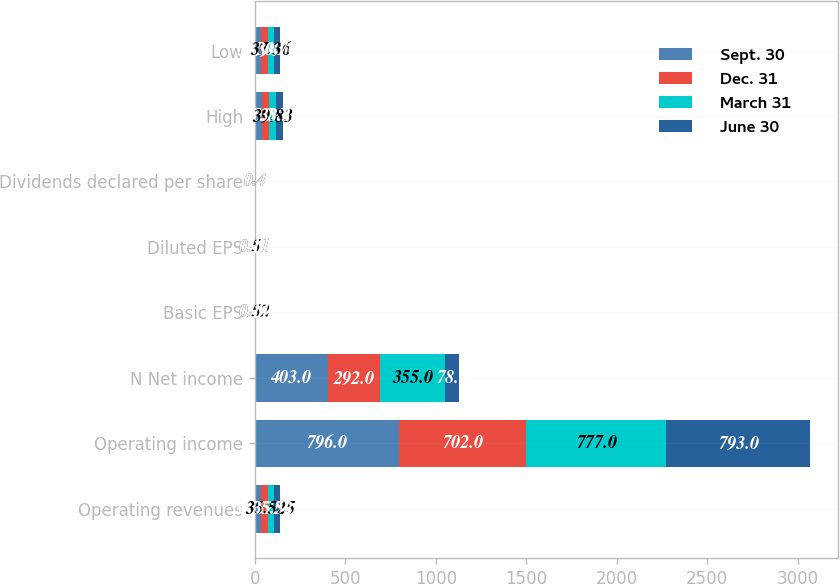<chart> <loc_0><loc_0><loc_500><loc_500><stacked_bar_chart><ecel><fcel>Operating revenues<fcel>Operating income<fcel>N Net income<fcel>Basic EPS<fcel>Diluted EPS<fcel>Dividends declared per share<fcel>High<fcel>Low<nl><fcel>Sept. 30<fcel>35.525<fcel>796<fcel>403<fcel>0.59<fcel>0.59<fcel>0.4<fcel>37.7<fcel>33.94<nl><fcel>Dec. 31<fcel>35.525<fcel>702<fcel>292<fcel>0.43<fcel>0.43<fcel>0.4<fcel>40.06<fcel>37.11<nl><fcel>March 31<fcel>35.525<fcel>777<fcel>355<fcel>0.52<fcel>0.51<fcel>0.4<fcel>39.83<fcel>37.36<nl><fcel>June 30<fcel>35.525<fcel>793<fcel>78<fcel>0.11<fcel>0.11<fcel>0.4<fcel>38.37<fcel>30.76<nl></chart> 